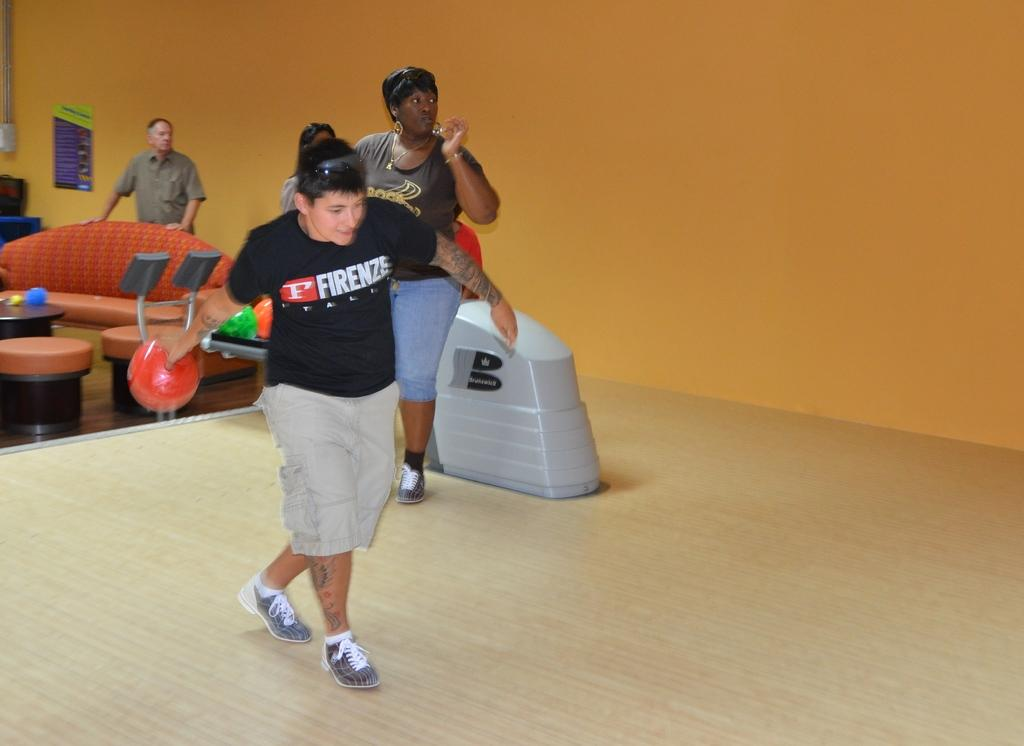What are the people in the image doing? The people in the image are standing. What object is being held by one of the people? A person is holding a ball. What type of furniture is present in the image? There is a sofa and chairs in the image. What can be seen on the table in the image? There are objects on a table. What is on the wall in the image? There is a poster on a wall. Can you see any boats in the harbor in the image? There is no harbor or boats present in the image. What type of bead is being used for the operation in the image? There is no operation or bead present in the image. 